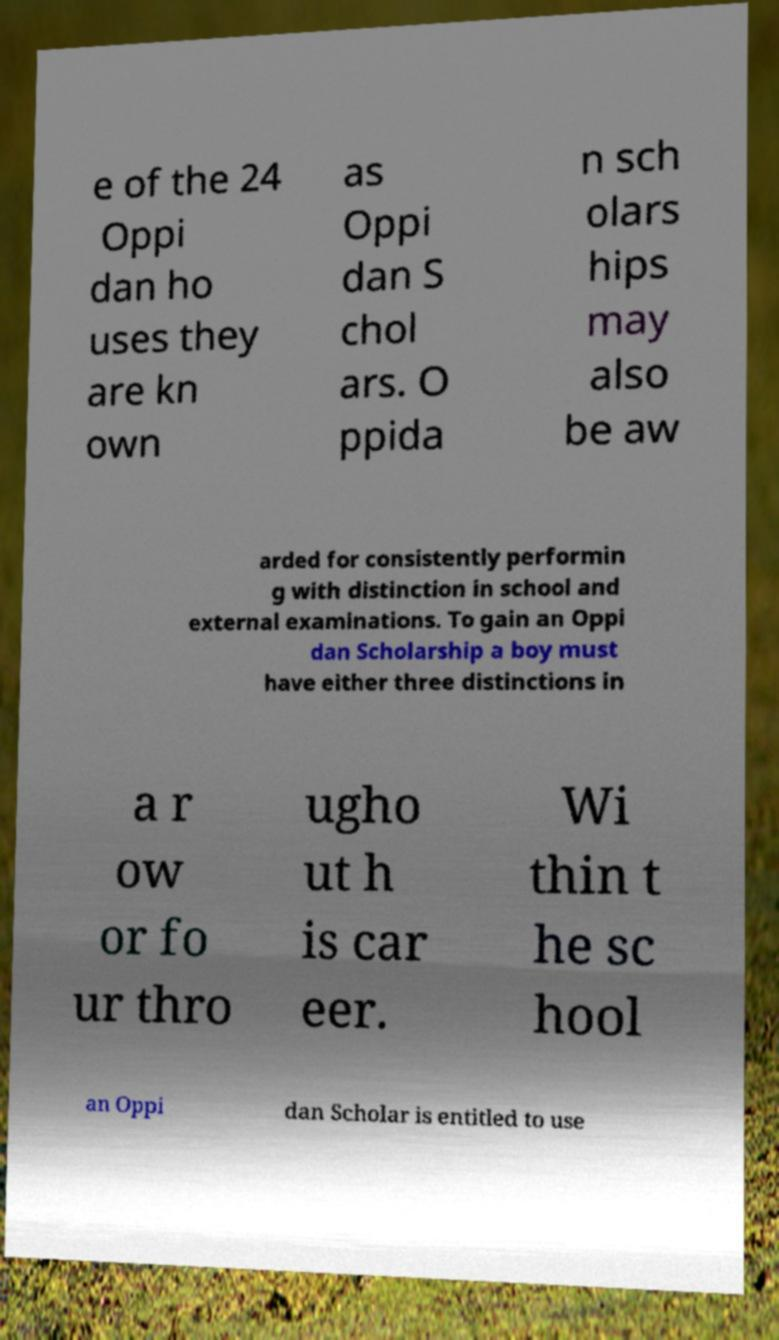Please read and relay the text visible in this image. What does it say? e of the 24 Oppi dan ho uses they are kn own as Oppi dan S chol ars. O ppida n sch olars hips may also be aw arded for consistently performin g with distinction in school and external examinations. To gain an Oppi dan Scholarship a boy must have either three distinctions in a r ow or fo ur thro ugho ut h is car eer. Wi thin t he sc hool an Oppi dan Scholar is entitled to use 